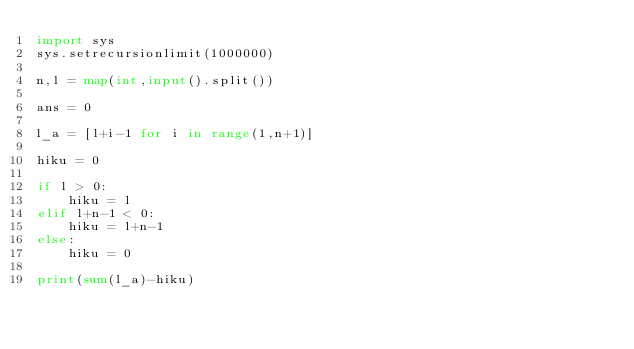Convert code to text. <code><loc_0><loc_0><loc_500><loc_500><_Python_>import sys
sys.setrecursionlimit(1000000)
 
n,l = map(int,input().split())

ans = 0

l_a = [l+i-1 for i in range(1,n+1)]

hiku = 0

if l > 0:
    hiku = l
elif l+n-1 < 0:
    hiku = l+n-1
else:
    hiku = 0

print(sum(l_a)-hiku)</code> 